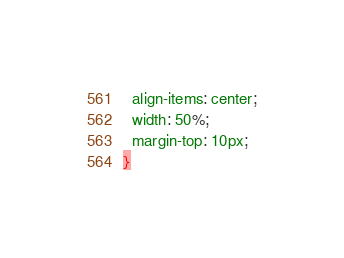Convert code to text. <code><loc_0><loc_0><loc_500><loc_500><_CSS_>  align-items: center;
  width: 50%;
  margin-top: 10px;
}</code> 